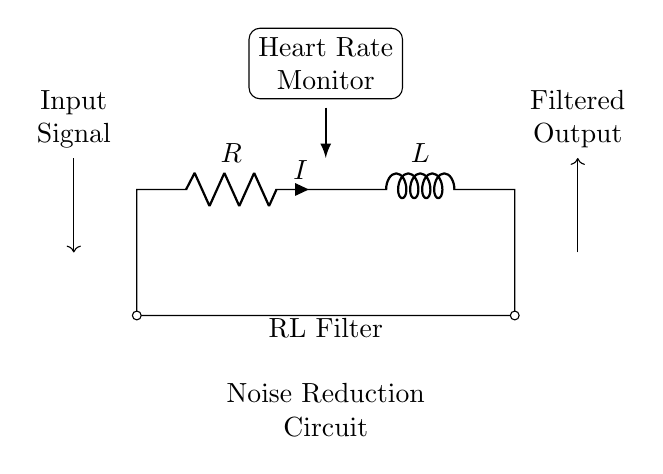What components are included in the RL filter? The circuit has a resistor and an inductor, which are the two components that make up the RL filter. The resistor is labeled as R and the inductor is labeled as L in the diagram.
Answer: resistor and inductor What does the arrow pointing towards the right represent? The arrow indicates the direction of the filtered output signal, showing that the RL filter processes the input signal to produce a clean output.
Answer: Filtered output What is the role of the resistor in this circuit? The resistor helps to control the current flow and dissipates energy, playing a key role in limiting the maximum current that can pass through the circuit.
Answer: Control current How is the input signal represented in the diagram? The input signal is shown as an arrow pointing into the circuit, with a label that identifies it as the input signal. This indicates where the raw signal enters the RL filter.
Answer: Input signal Why is an RL filter used in a heart rate monitor? An RL filter is used in a heart rate monitor to reduce noise from the input signal, allowing for a clearer representation of the heart rate data by filtering out unwanted variations.
Answer: Noise reduction What happens to the output signal as it passes through the RL filter? The output signal becomes smoother and less noisy as it passes through the RL filter, which effectively filters out fluctuations and disturbances in the input signal.
Answer: Smoother output What is the function of the inductor in this circuit? The inductor stores energy in a magnetic field when current passes through it and helps filter frequencies by opposing changes in current, contributing to the noise reduction.
Answer: Filters frequencies 